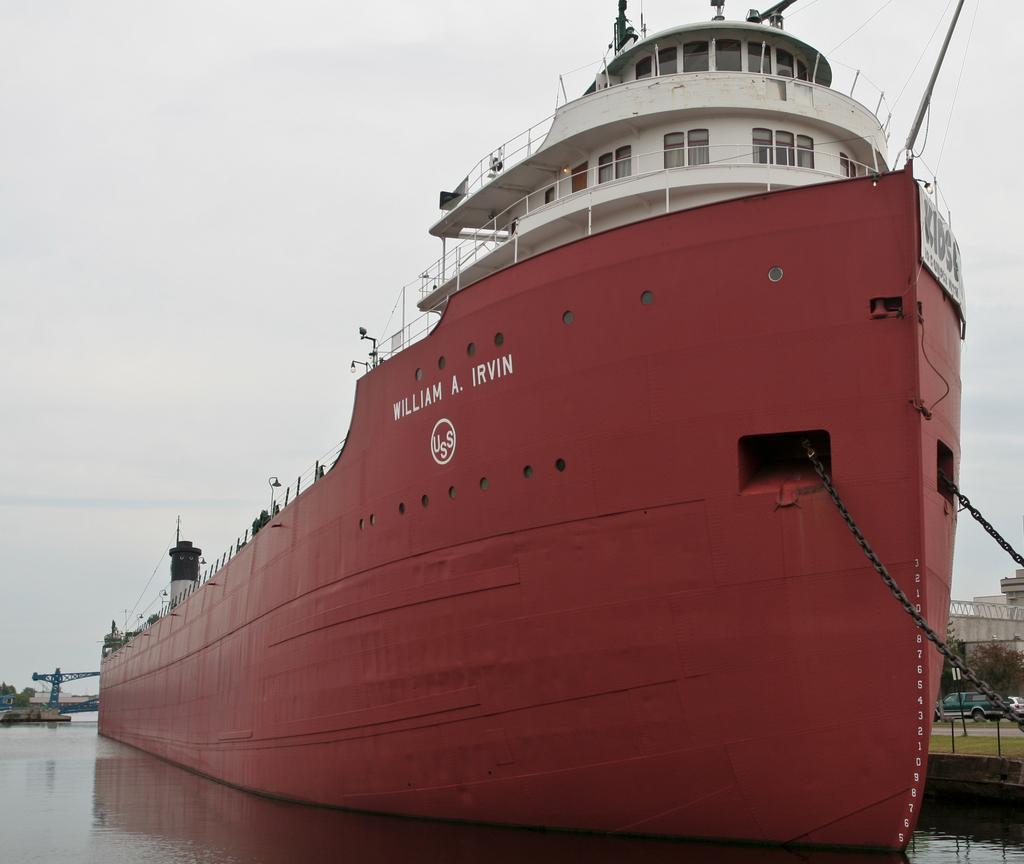Can you describe this image briefly? In this image I can see boats in the water. In the background I can see trees, vehicles on the road, buildings and the sky. This image is taken may be in the lake during a day. 